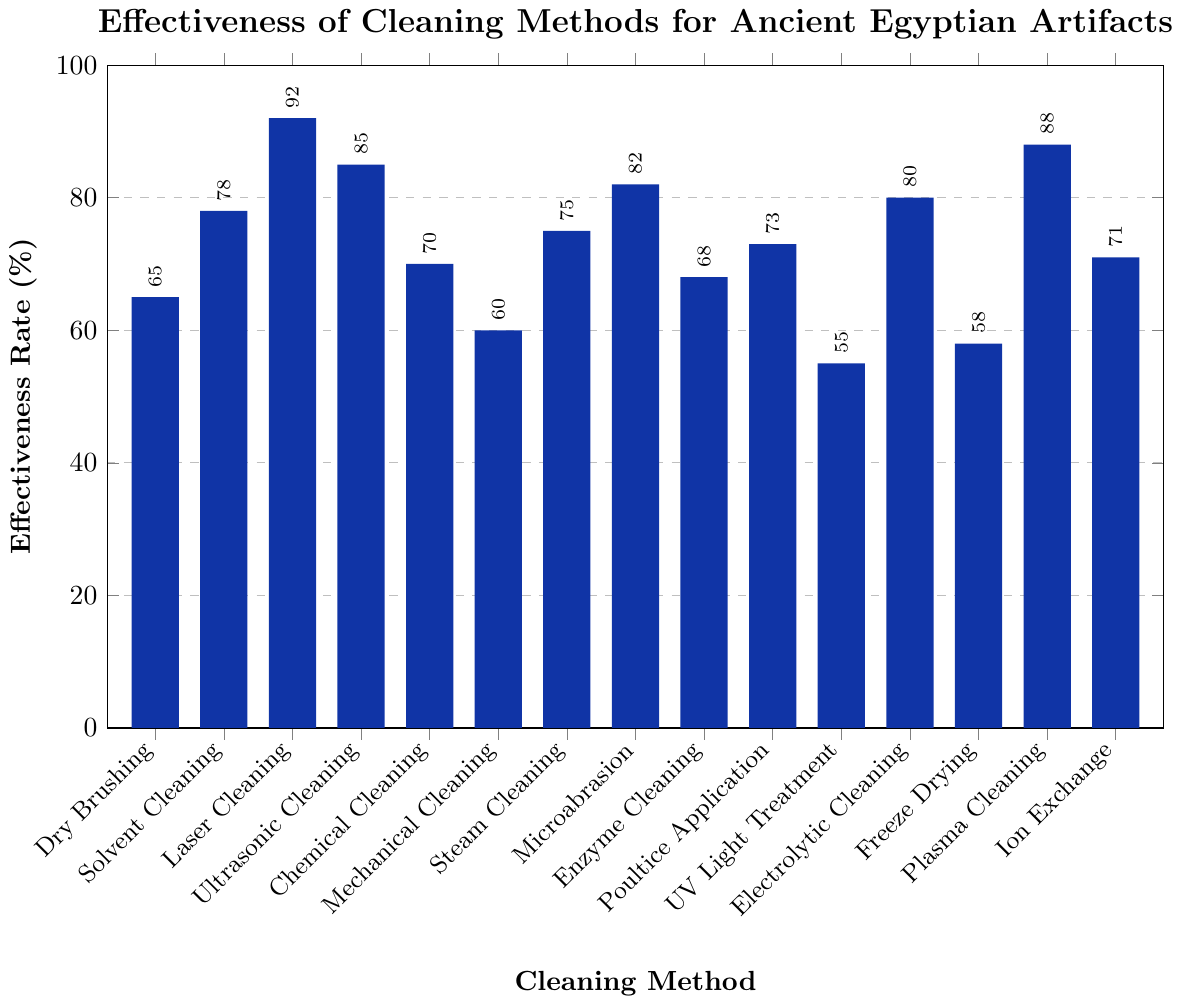Which cleaning method has the highest effectiveness rate? By looking at the heights of the bar values, the highest bar represents the method with the highest effectiveness rate.
Answer: Laser Cleaning Which cleaning method has the lowest effectiveness rate? By looking at the bar values, the shortest bar represents the method with the lowest effectiveness rate.
Answer: UV Light Treatment How much more effective is Laser Cleaning compared to Dry Brushing? Subtract the effectiveness rate of Dry Brushing from that of Laser Cleaning: 92% - 65% = 27%.
Answer: 27% What is the average effectiveness rate of the top three most effective cleaning methods? Identify the top three methods (Laser Cleaning, Plasma Cleaning, and Ultrasonic Cleaning with rates 92%, 88%, and 85% respectively). Calculate the average: (92 + 88 + 85)/3 ≈ 88.33%.
Answer: 88.33% How many cleaning methods have an effectiveness rate of 70% or higher? Count the methods with effectiveness rates 70% or higher. There are Solvent Cleaning (78%), Laser Cleaning (92%), Ultrasonic Cleaning (85%), Chemical Cleaning (70%), Steam Cleaning (75%), Microabrasion (82%), Electrolytic Cleaning (80%), Plasma Cleaning (88%), and Ion Exchange (71%). There are 9 methods.
Answer: 9 Which cleaning method is more effective, Mechanical Cleaning or Freeze Drying? By how much? Compare the effectiveness rates of Mechanical Cleaning (60%) and Freeze Drying (58%). Mechanical Cleaning is more effective. Subtract the effectiveness rate of Freeze Drying from that of Mechanical Cleaning: 60% - 58% = 2%.
Answer: Mechanical Cleaning, 2% What is the total sum of effectiveness rates for Dry Brushing, Enzyme Cleaning, and Poultice Application? Add the effectiveness rates of these methods: 65% (Dry Brushing) + 68% (Enzyme Cleaning) + 73% (Poultice Application) = 206%.
Answer: 206% What is the effectiveness rate range of all the cleaning methods? Subtract the lowest effectiveness rate from the highest effectiveness rate: 92% (Laser Cleaning) - 55% (UV Light Treatment) = 37%.
Answer: 37% If you were to rank Ultrasonic Cleaning, Poultice Application, and Chemical Cleaning, which one comes in the middle in terms of effectiveness? Compare the effectiveness rates: Ultrasonic Cleaning (85%), Poultice Application (73%), and Chemical Cleaning (70%). The middle value is for Poultice Application.
Answer: Poultice Application What is the difference in effectiveness rates between Solvent Cleaning and Enzyme Cleaning? Subtract the effectiveness rate of Enzyme Cleaning from that of Solvent Cleaning: 78% - 68% = 10%.
Answer: 10% 